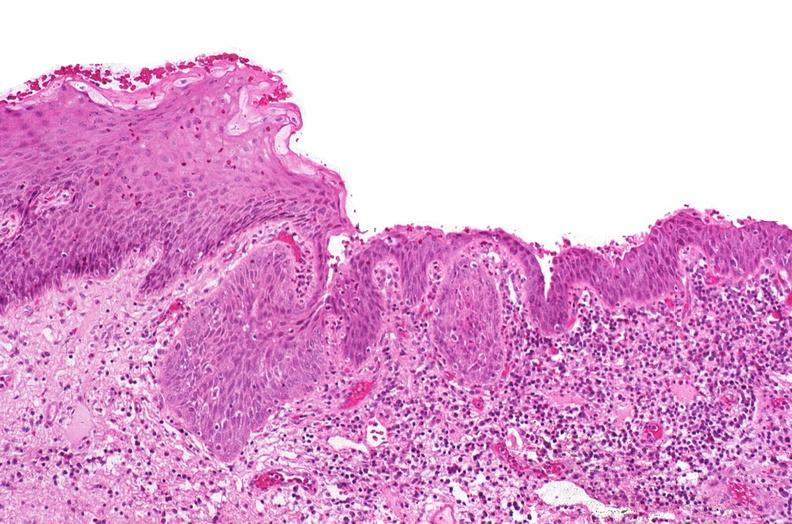does opened larynx show renal pelvis, squamous metaplasia due to chronic urolithiasis?
Answer the question using a single word or phrase. No 